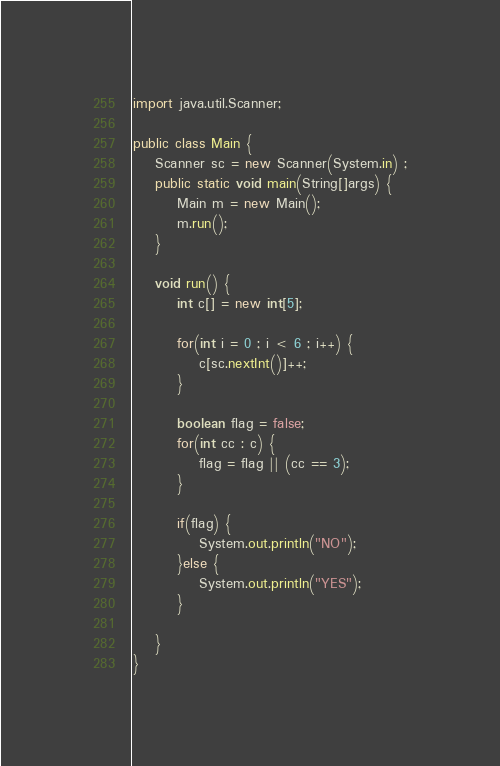<code> <loc_0><loc_0><loc_500><loc_500><_Java_>import java.util.Scanner;

public class Main {
	Scanner sc = new Scanner(System.in) ;
	public static void main(String[]args) {
		Main m = new Main();
		m.run();
	}
	
	void run() {
		int c[] = new int[5];
		
		for(int i = 0 ; i < 6 ; i++) {
			c[sc.nextInt()]++;
		}
		
		boolean flag = false;
		for(int cc : c) {
			flag = flag || (cc == 3);
		}
		
		if(flag) {
			System.out.println("NO");
		}else {
			System.out.println("YES");
		}
		
	}
}</code> 